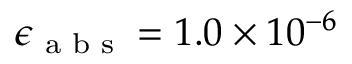Convert formula to latex. <formula><loc_0><loc_0><loc_500><loc_500>\epsilon _ { a b s } = 1 . 0 \times 1 0 ^ { - 6 }</formula> 